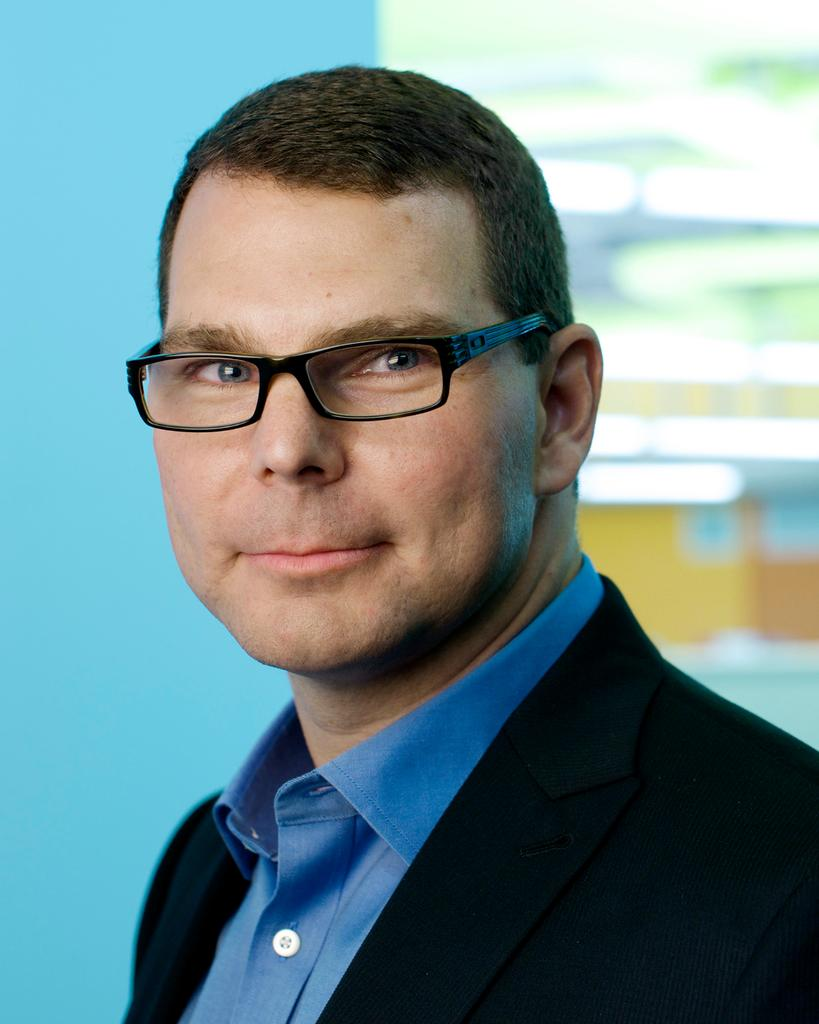What is the main subject of the image? There is a person in the image. What is the person's facial expression? The person is smiling. Can you describe the background of the image? The background is blurry. What type of breakfast is the person holding in the image? There is no breakfast present in the image; it only features a person with a blurry background. 